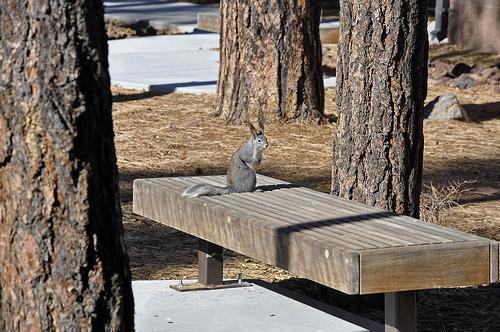How many squirrels are in the picture?
Give a very brief answer. 1. 